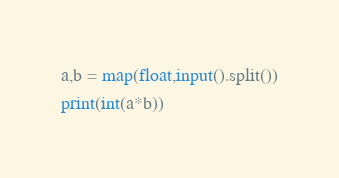Convert code to text. <code><loc_0><loc_0><loc_500><loc_500><_Python_>a,b = map(float,input().split())
print(int(a*b))</code> 